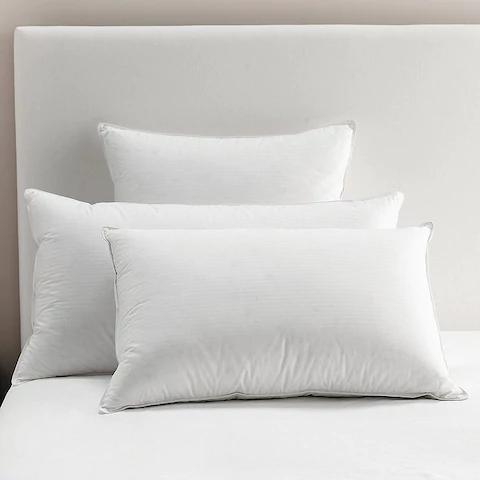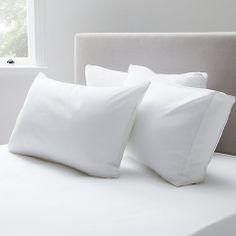The first image is the image on the left, the second image is the image on the right. Examine the images to the left and right. Is the description "There are more pillows in the image on the right." accurate? Answer yes or no. No. The first image is the image on the left, the second image is the image on the right. Analyze the images presented: Is the assertion "One image features a sculpted pillow style with a concave shape, and the other image features a pillow style with pointed corners." valid? Answer yes or no. No. 